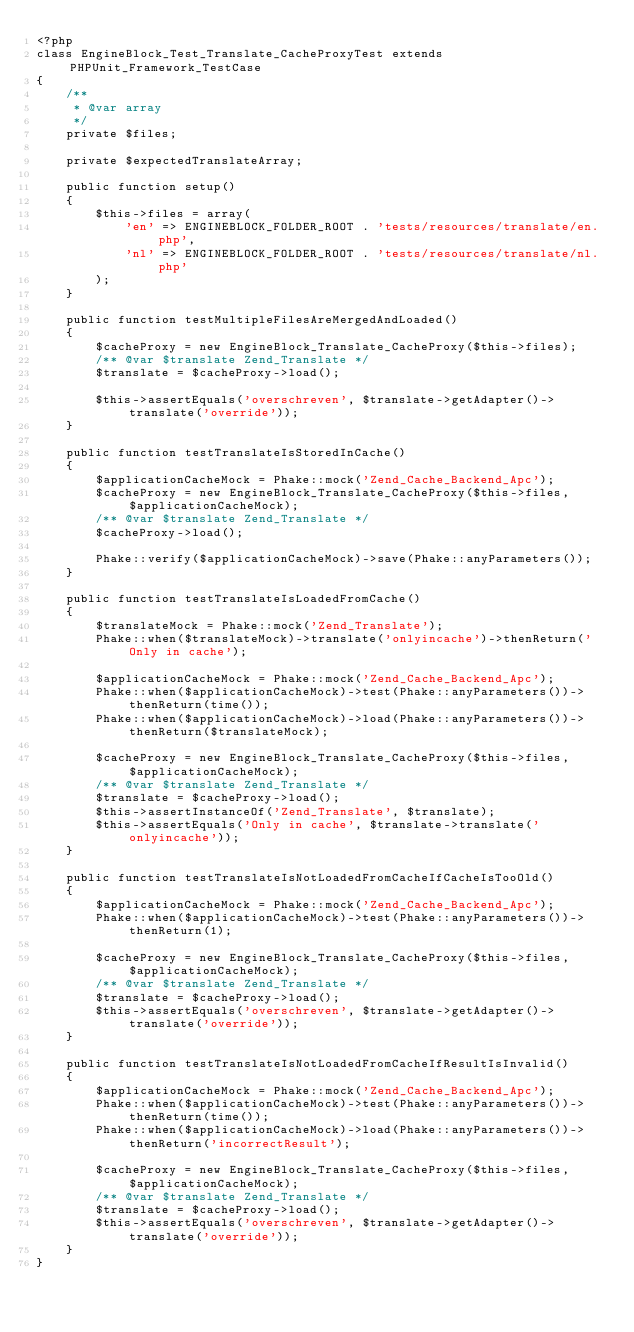Convert code to text. <code><loc_0><loc_0><loc_500><loc_500><_PHP_><?php
class EngineBlock_Test_Translate_CacheProxyTest extends PHPUnit_Framework_TestCase
{
    /**
     * @var array
     */
    private $files;

    private $expectedTranslateArray;

    public function setup()
    {
        $this->files = array(
            'en' => ENGINEBLOCK_FOLDER_ROOT . 'tests/resources/translate/en.php',
            'nl' => ENGINEBLOCK_FOLDER_ROOT . 'tests/resources/translate/nl.php'
        );
    }

    public function testMultipleFilesAreMergedAndLoaded()
    {
        $cacheProxy = new EngineBlock_Translate_CacheProxy($this->files);
        /** @var $translate Zend_Translate */
        $translate = $cacheProxy->load();

        $this->assertEquals('overschreven', $translate->getAdapter()->translate('override'));
    }

    public function testTranslateIsStoredInCache()
    {
        $applicationCacheMock = Phake::mock('Zend_Cache_Backend_Apc');
        $cacheProxy = new EngineBlock_Translate_CacheProxy($this->files, $applicationCacheMock);
        /** @var $translate Zend_Translate */
        $cacheProxy->load();

        Phake::verify($applicationCacheMock)->save(Phake::anyParameters());
    }

    public function testTranslateIsLoadedFromCache()
    {
        $translateMock = Phake::mock('Zend_Translate');
        Phake::when($translateMock)->translate('onlyincache')->thenReturn('Only in cache');

        $applicationCacheMock = Phake::mock('Zend_Cache_Backend_Apc');
        Phake::when($applicationCacheMock)->test(Phake::anyParameters())->thenReturn(time());
        Phake::when($applicationCacheMock)->load(Phake::anyParameters())->thenReturn($translateMock);

        $cacheProxy = new EngineBlock_Translate_CacheProxy($this->files, $applicationCacheMock);
        /** @var $translate Zend_Translate */
        $translate = $cacheProxy->load();
        $this->assertInstanceOf('Zend_Translate', $translate);
        $this->assertEquals('Only in cache', $translate->translate('onlyincache'));
    }

    public function testTranslateIsNotLoadedFromCacheIfCacheIsTooOld()
    {
        $applicationCacheMock = Phake::mock('Zend_Cache_Backend_Apc');
        Phake::when($applicationCacheMock)->test(Phake::anyParameters())->thenReturn(1);

        $cacheProxy = new EngineBlock_Translate_CacheProxy($this->files, $applicationCacheMock);
        /** @var $translate Zend_Translate */
        $translate = $cacheProxy->load();
        $this->assertEquals('overschreven', $translate->getAdapter()->translate('override'));
    }

    public function testTranslateIsNotLoadedFromCacheIfResultIsInvalid()
    {
        $applicationCacheMock = Phake::mock('Zend_Cache_Backend_Apc');
        Phake::when($applicationCacheMock)->test(Phake::anyParameters())->thenReturn(time());
        Phake::when($applicationCacheMock)->load(Phake::anyParameters())->thenReturn('incorrectResult');

        $cacheProxy = new EngineBlock_Translate_CacheProxy($this->files, $applicationCacheMock);
        /** @var $translate Zend_Translate */
        $translate = $cacheProxy->load();
        $this->assertEquals('overschreven', $translate->getAdapter()->translate('override'));
    }
}
</code> 